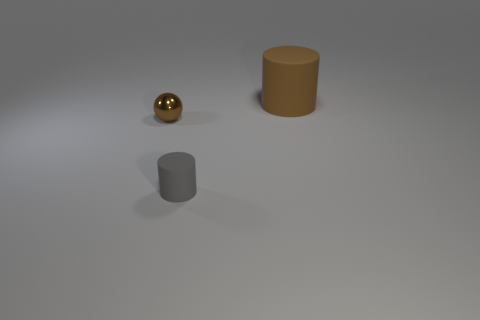Add 3 red cubes. How many objects exist? 6 Subtract all spheres. How many objects are left? 2 Add 3 tiny brown things. How many tiny brown things are left? 4 Add 3 brown rubber objects. How many brown rubber objects exist? 4 Subtract 0 red cubes. How many objects are left? 3 Subtract all tiny purple matte cylinders. Subtract all matte objects. How many objects are left? 1 